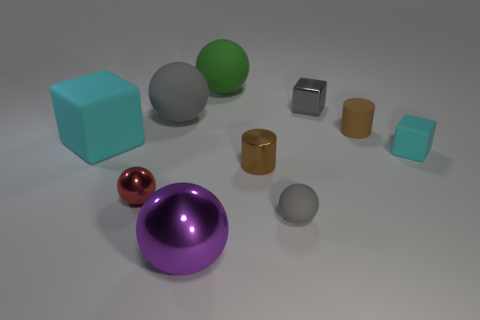Subtract all matte cubes. How many cubes are left? 1 Subtract all cyan blocks. How many blocks are left? 1 Subtract 1 blocks. How many blocks are left? 2 Subtract all cubes. How many objects are left? 7 Subtract all purple spheres. Subtract all green matte objects. How many objects are left? 8 Add 9 tiny metallic cylinders. How many tiny metallic cylinders are left? 10 Add 2 big purple balls. How many big purple balls exist? 3 Subtract 0 red cubes. How many objects are left? 10 Subtract all blue cylinders. Subtract all yellow balls. How many cylinders are left? 2 Subtract all blue blocks. How many cyan cylinders are left? 0 